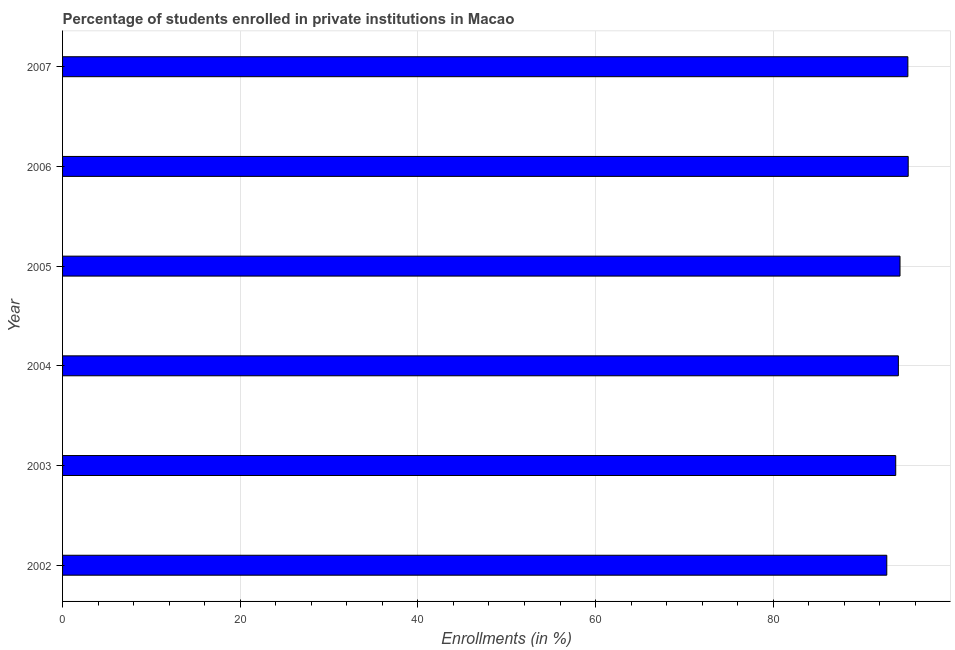Does the graph contain grids?
Keep it short and to the point. Yes. What is the title of the graph?
Offer a very short reply. Percentage of students enrolled in private institutions in Macao. What is the label or title of the X-axis?
Give a very brief answer. Enrollments (in %). What is the enrollments in private institutions in 2004?
Offer a very short reply. 94.08. Across all years, what is the maximum enrollments in private institutions?
Offer a very short reply. 95.19. Across all years, what is the minimum enrollments in private institutions?
Your answer should be very brief. 92.78. What is the sum of the enrollments in private institutions?
Your answer should be very brief. 565.26. What is the difference between the enrollments in private institutions in 2004 and 2006?
Offer a terse response. -1.11. What is the average enrollments in private institutions per year?
Make the answer very short. 94.21. What is the median enrollments in private institutions?
Provide a succinct answer. 94.18. In how many years, is the enrollments in private institutions greater than 20 %?
Provide a succinct answer. 6. Do a majority of the years between 2002 and 2005 (inclusive) have enrollments in private institutions greater than 88 %?
Offer a terse response. Yes. Is the enrollments in private institutions in 2002 less than that in 2006?
Give a very brief answer. Yes. What is the difference between the highest and the second highest enrollments in private institutions?
Provide a short and direct response. 0.04. What is the difference between the highest and the lowest enrollments in private institutions?
Give a very brief answer. 2.41. How many bars are there?
Offer a terse response. 6. How many years are there in the graph?
Provide a succinct answer. 6. What is the Enrollments (in %) of 2002?
Give a very brief answer. 92.78. What is the Enrollments (in %) of 2003?
Offer a very short reply. 93.79. What is the Enrollments (in %) in 2004?
Offer a terse response. 94.08. What is the Enrollments (in %) of 2005?
Offer a terse response. 94.27. What is the Enrollments (in %) in 2006?
Your answer should be compact. 95.19. What is the Enrollments (in %) of 2007?
Give a very brief answer. 95.15. What is the difference between the Enrollments (in %) in 2002 and 2003?
Your answer should be compact. -1.01. What is the difference between the Enrollments (in %) in 2002 and 2004?
Your response must be concise. -1.3. What is the difference between the Enrollments (in %) in 2002 and 2005?
Your answer should be very brief. -1.49. What is the difference between the Enrollments (in %) in 2002 and 2006?
Provide a succinct answer. -2.41. What is the difference between the Enrollments (in %) in 2002 and 2007?
Provide a succinct answer. -2.37. What is the difference between the Enrollments (in %) in 2003 and 2004?
Your answer should be compact. -0.3. What is the difference between the Enrollments (in %) in 2003 and 2005?
Keep it short and to the point. -0.48. What is the difference between the Enrollments (in %) in 2003 and 2006?
Your response must be concise. -1.41. What is the difference between the Enrollments (in %) in 2003 and 2007?
Offer a terse response. -1.37. What is the difference between the Enrollments (in %) in 2004 and 2005?
Offer a terse response. -0.19. What is the difference between the Enrollments (in %) in 2004 and 2006?
Provide a short and direct response. -1.11. What is the difference between the Enrollments (in %) in 2004 and 2007?
Provide a short and direct response. -1.07. What is the difference between the Enrollments (in %) in 2005 and 2006?
Your answer should be very brief. -0.92. What is the difference between the Enrollments (in %) in 2005 and 2007?
Give a very brief answer. -0.88. What is the difference between the Enrollments (in %) in 2006 and 2007?
Make the answer very short. 0.04. What is the ratio of the Enrollments (in %) in 2002 to that in 2004?
Provide a short and direct response. 0.99. What is the ratio of the Enrollments (in %) in 2003 to that in 2004?
Provide a succinct answer. 1. What is the ratio of the Enrollments (in %) in 2003 to that in 2005?
Offer a terse response. 0.99. What is the ratio of the Enrollments (in %) in 2004 to that in 2006?
Your response must be concise. 0.99. What is the ratio of the Enrollments (in %) in 2004 to that in 2007?
Give a very brief answer. 0.99. What is the ratio of the Enrollments (in %) in 2005 to that in 2007?
Your answer should be compact. 0.99. 